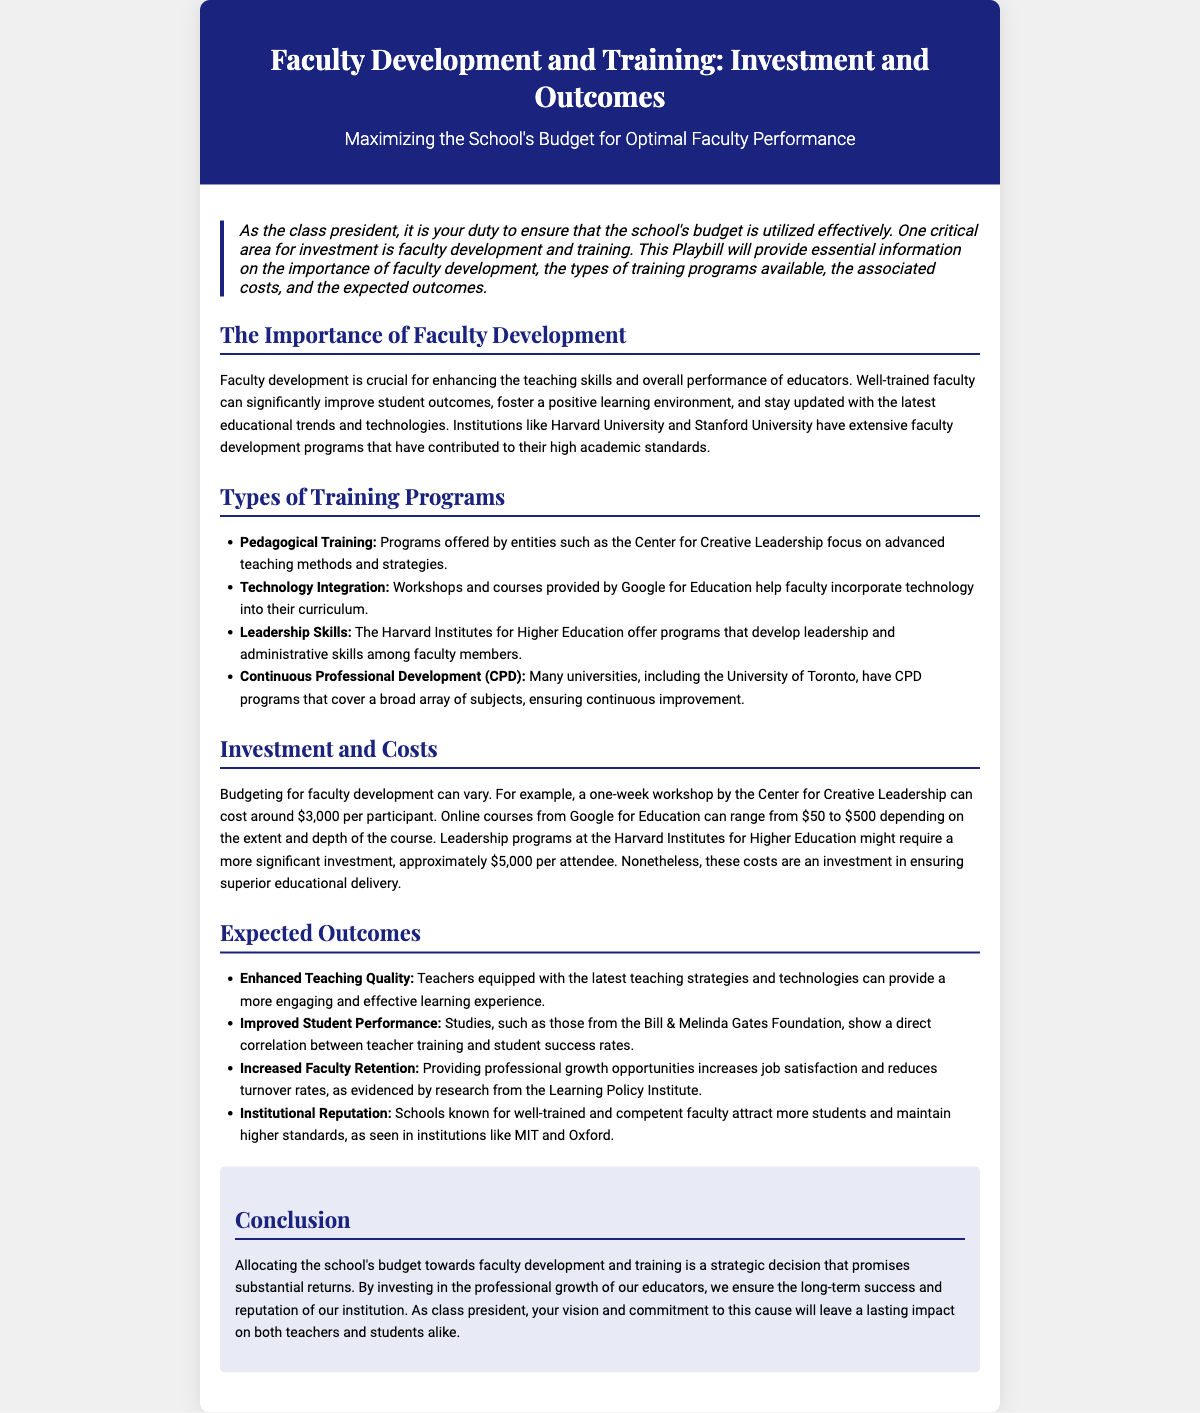What is the title of the Playbill? The title is prominently displayed in the header section of the document, showing the focus of the content.
Answer: Faculty Development and Training: Investment and Outcomes What is the cost for a one-week workshop by the Center for Creative Leadership? This cost is outlined in the Investment and Costs section, providing specific pricing for training programs.
Answer: $3,000 Which institution is mentioned for its continuous professional development programs? This information is found in the Types of Training Programs section, showcasing various institutions involved in faculty development.
Answer: University of Toronto What type of training program focuses on advanced teaching methods? The document lists various training types, specifying what each focuses on in the Types of Training Programs section.
Answer: Pedagogical Training What is a key benefit of enhanced teaching quality mentioned in the document? The Expected Outcomes section discusses the positive impacts of improved teaching methods on student experiences.
Answer: More engaging and effective learning experience Which foundation is cited for showing a correlation between teacher training and student performance? This information can be found in the Expected Outcomes section, providing evidence for the effectiveness of faculty training.
Answer: Bill & Melinda Gates Foundation What color is used for the header background? The design choices, including color schemes, are detailed in the HTML style section.
Answer: Dark blue What is the subtitle of the Playbill? The subtitle provides additional context about the primary focus of the document and is found under the title.
Answer: Maximizing the School's Budget for Optimal Faculty Performance Which institute offers programs that develop leadership skills among faculty members? This is found in the list of training programs, highlighting institutions that provide specific training types.
Answer: Harvard Institutes for Higher Education 